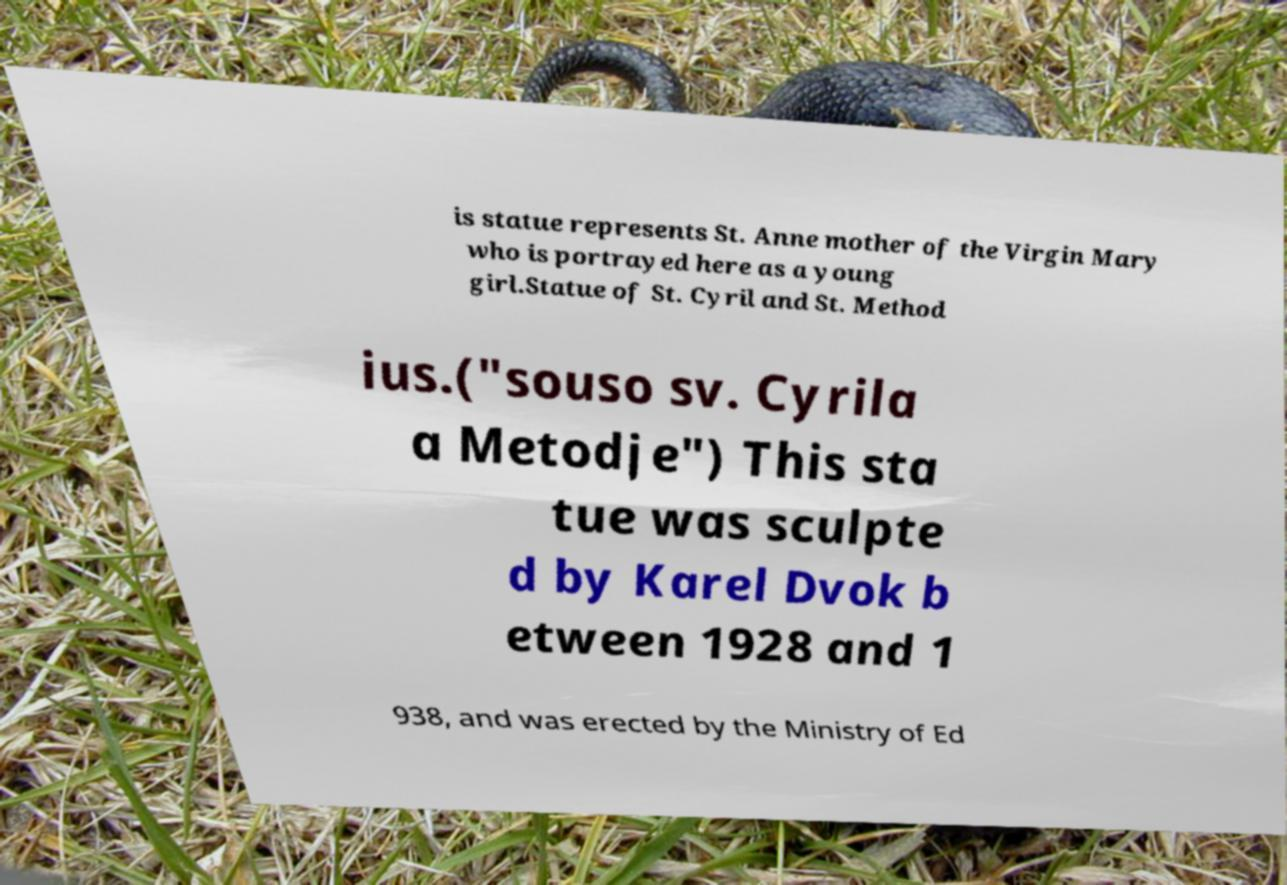Could you assist in decoding the text presented in this image and type it out clearly? is statue represents St. Anne mother of the Virgin Mary who is portrayed here as a young girl.Statue of St. Cyril and St. Method ius.("souso sv. Cyrila a Metodje") This sta tue was sculpte d by Karel Dvok b etween 1928 and 1 938, and was erected by the Ministry of Ed 